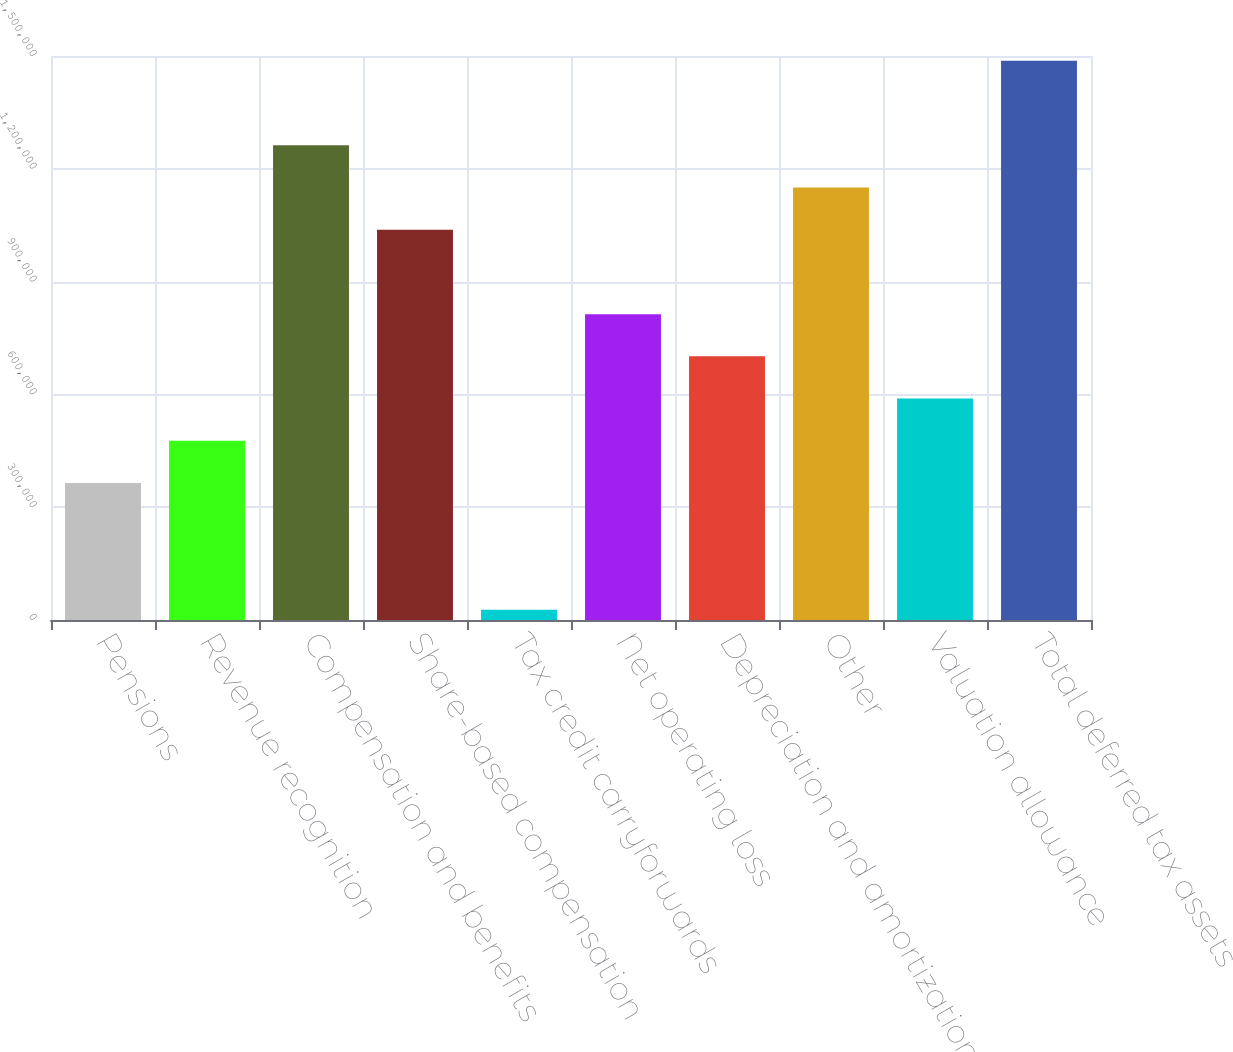<chart> <loc_0><loc_0><loc_500><loc_500><bar_chart><fcel>Pensions<fcel>Revenue recognition<fcel>Compensation and benefits<fcel>Share-based compensation<fcel>Tax credit carryforwards<fcel>Net operating loss<fcel>Depreciation and amortization<fcel>Other<fcel>Valuation allowance<fcel>Total deferred tax assets<nl><fcel>364288<fcel>476571<fcel>1.26255e+06<fcel>1.03798e+06<fcel>27441<fcel>813418<fcel>701135<fcel>1.15026e+06<fcel>588853<fcel>1.48711e+06<nl></chart> 